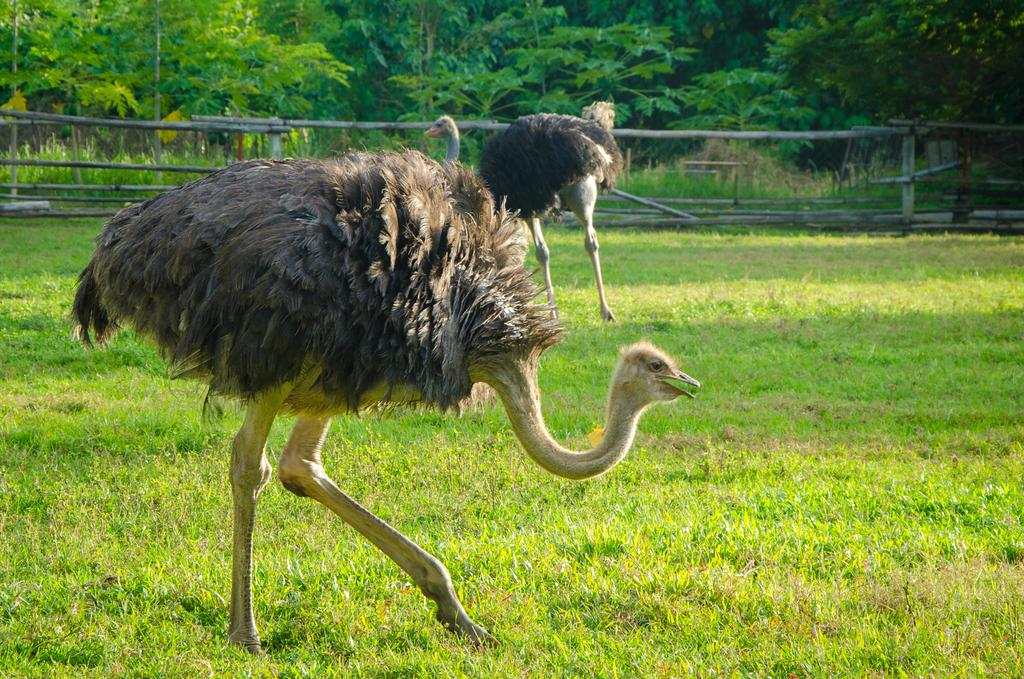What type of animals are in the image? There are ostriches in the image. What is the position of the ostriches in the image? The ostriches are standing on the ground. What is the ground covered with? The ground is covered with grass. What can be seen in the background of the image? There are trees visible in the background of the image. What type of noise can be heard coming from the cow in the image? There is no cow present in the image, so it is not possible to determine what noise might be heard. 